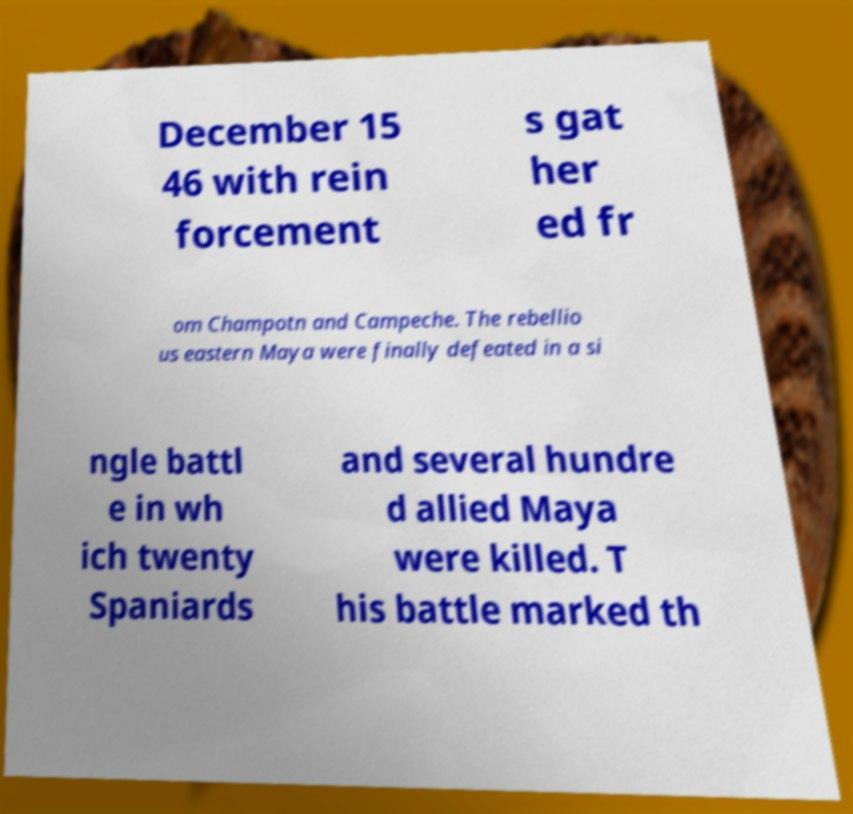What messages or text are displayed in this image? I need them in a readable, typed format. December 15 46 with rein forcement s gat her ed fr om Champotn and Campeche. The rebellio us eastern Maya were finally defeated in a si ngle battl e in wh ich twenty Spaniards and several hundre d allied Maya were killed. T his battle marked th 